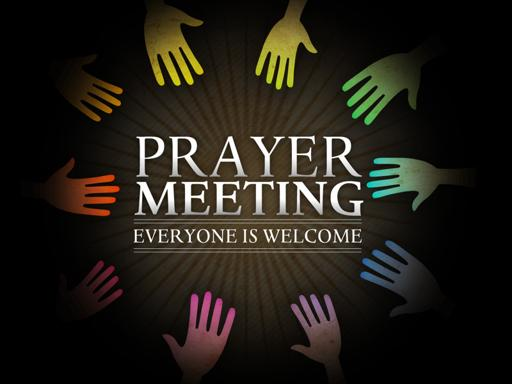Based on the image of a circle of hands, what can be inferred about the prayer meeting atmosphere? The image of a circle of hands powerfully conveys a message of unity and collective support. It suggests that the prayer meeting is designed to be a comforting and strengthening space where individuals feel connected and uplifted through shared spiritual practice. 